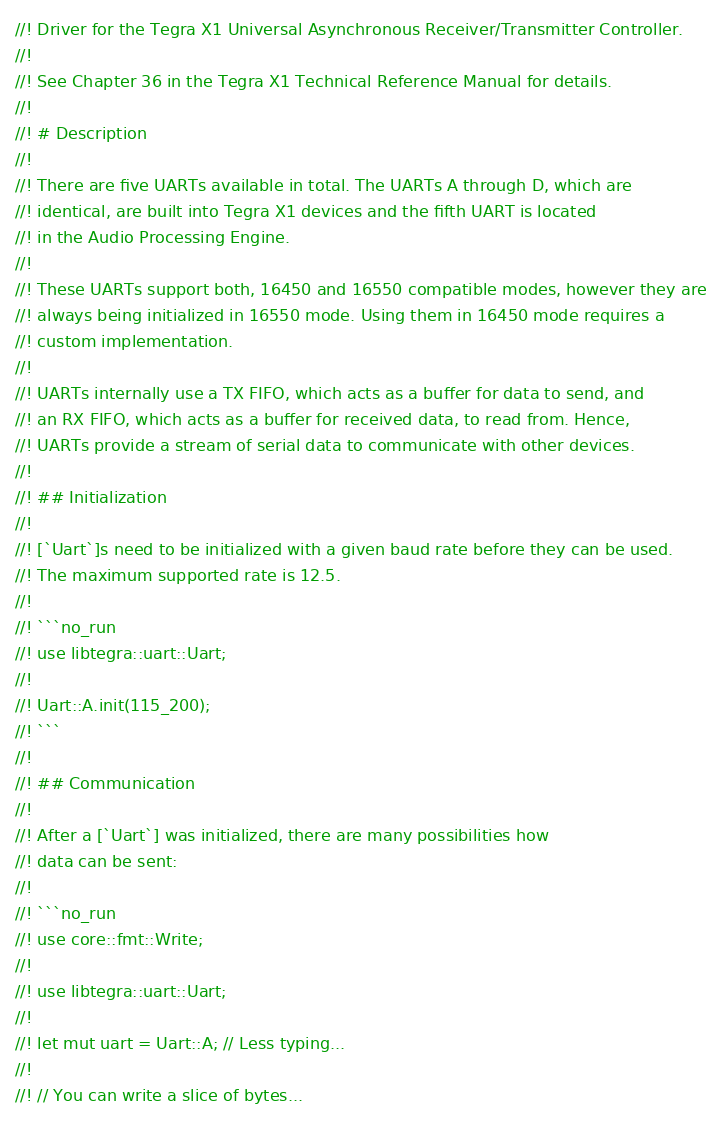Convert code to text. <code><loc_0><loc_0><loc_500><loc_500><_Rust_>//! Driver for the Tegra X1 Universal Asynchronous Receiver/Transmitter Controller.
//!
//! See Chapter 36 in the Tegra X1 Technical Reference Manual for details.
//!
//! # Description
//!
//! There are five UARTs available in total. The UARTs A through D, which are
//! identical, are built into Tegra X1 devices and the fifth UART is located
//! in the Audio Processing Engine.
//!
//! These UARTs support both, 16450 and 16550 compatible modes, however they are
//! always being initialized in 16550 mode. Using them in 16450 mode requires a
//! custom implementation.
//!
//! UARTs internally use a TX FIFO, which acts as a buffer for data to send, and
//! an RX FIFO, which acts as a buffer for received data, to read from. Hence,
//! UARTs provide a stream of serial data to communicate with other devices.
//!
//! ## Initialization
//!
//! [`Uart`]s need to be initialized with a given baud rate before they can be used.
//! The maximum supported rate is 12.5.
//!
//! ```no_run
//! use libtegra::uart::Uart;
//!
//! Uart::A.init(115_200);
//! ```
//!
//! ## Communication
//!
//! After a [`Uart`] was initialized, there are many possibilities how
//! data can be sent:
//!
//! ```no_run
//! use core::fmt::Write;
//!
//! use libtegra::uart::Uart;
//!
//! let mut uart = Uart::A; // Less typing...
//!
//! // You can write a slice of bytes...</code> 